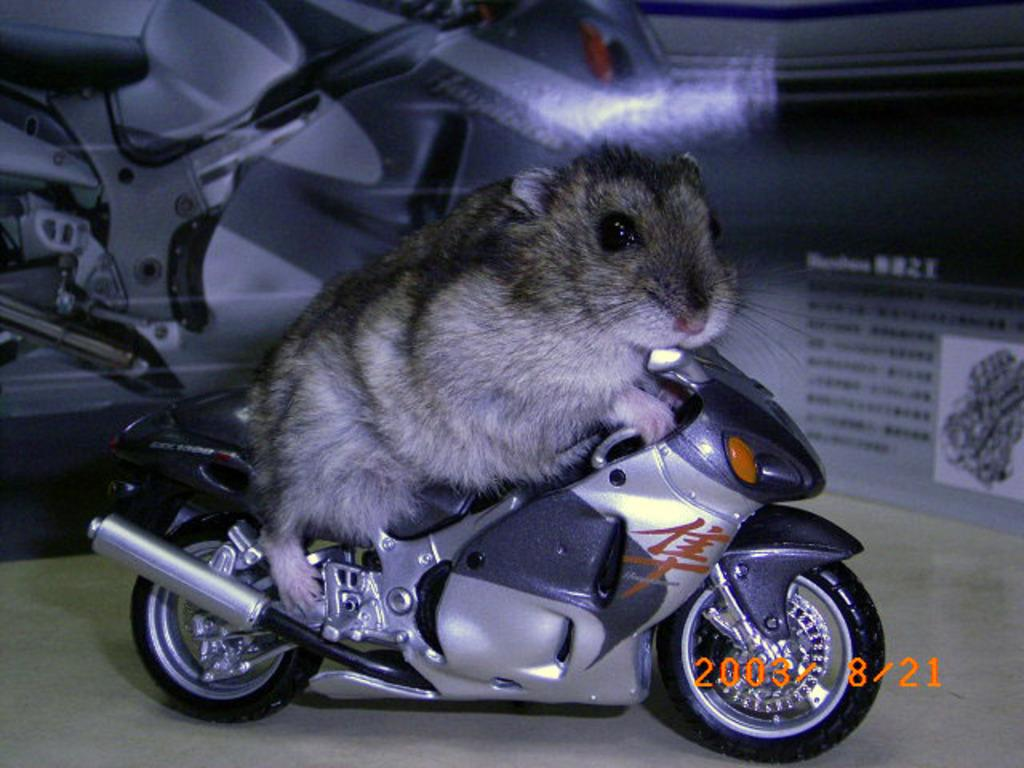What animal can be seen in the image? There is a mouse in the image. What is the mouse sitting on? The mouse is sitting on a motorbike toy. Is there any information about the date in the image? Yes, there is a date in the lower left corner of the image. What else related to vehicles can be seen in the image? There is a poster of a bike in the image. Can you describe the text on the bike poster? Yes, there is text on the bike poster. What type of steel is used to make the club in the image? There is no club present in the image, so it is not possible to determine the type of steel used. 